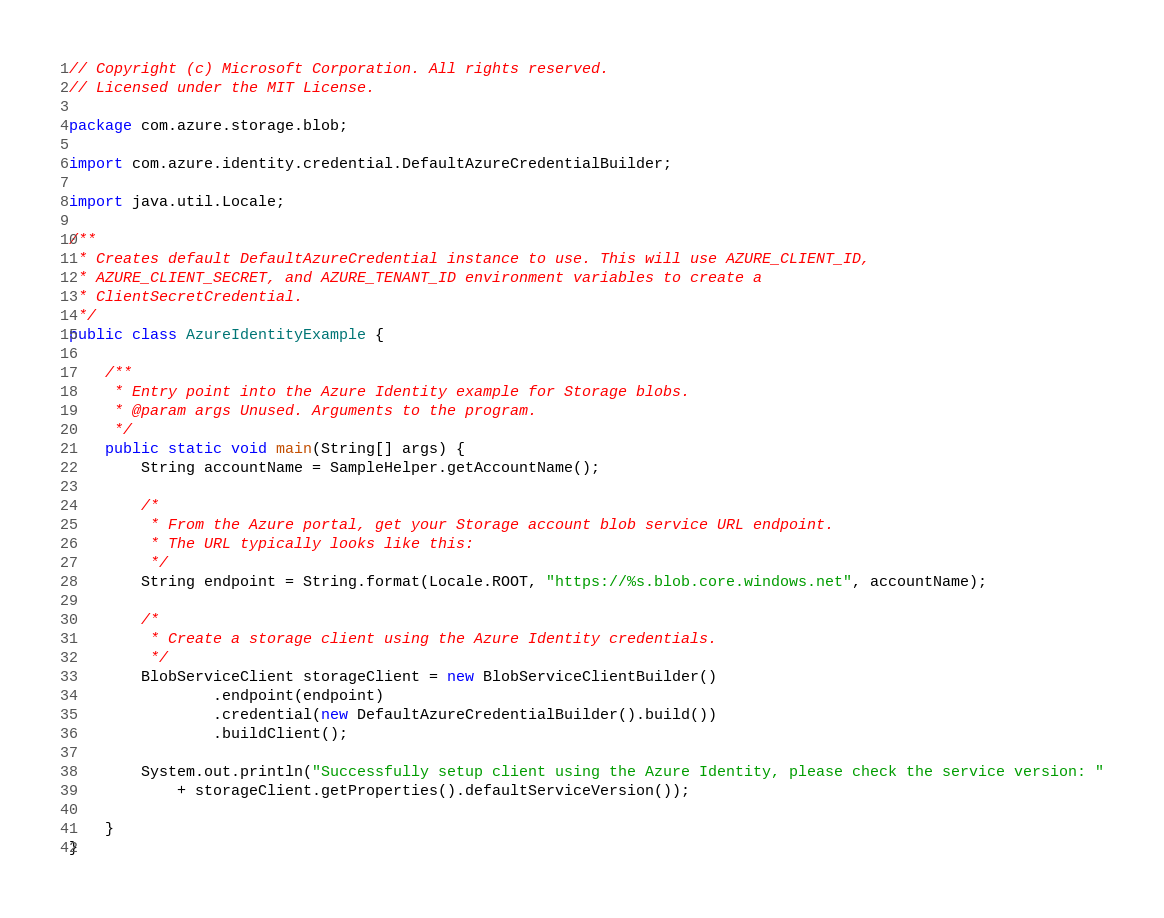<code> <loc_0><loc_0><loc_500><loc_500><_Java_>// Copyright (c) Microsoft Corporation. All rights reserved.
// Licensed under the MIT License.

package com.azure.storage.blob;

import com.azure.identity.credential.DefaultAzureCredentialBuilder;

import java.util.Locale;

/**
 * Creates default DefaultAzureCredential instance to use. This will use AZURE_CLIENT_ID,
 * AZURE_CLIENT_SECRET, and AZURE_TENANT_ID environment variables to create a
 * ClientSecretCredential.
 */
public class AzureIdentityExample {

    /**
     * Entry point into the Azure Identity example for Storage blobs.
     * @param args Unused. Arguments to the program.
     */
    public static void main(String[] args) {
        String accountName = SampleHelper.getAccountName();

        /*
         * From the Azure portal, get your Storage account blob service URL endpoint.
         * The URL typically looks like this:
         */
        String endpoint = String.format(Locale.ROOT, "https://%s.blob.core.windows.net", accountName);

        /*
         * Create a storage client using the Azure Identity credentials.
         */
        BlobServiceClient storageClient = new BlobServiceClientBuilder()
                .endpoint(endpoint)
                .credential(new DefaultAzureCredentialBuilder().build())
                .buildClient();

        System.out.println("Successfully setup client using the Azure Identity, please check the service version: "
            + storageClient.getProperties().defaultServiceVersion());

    }
}
</code> 